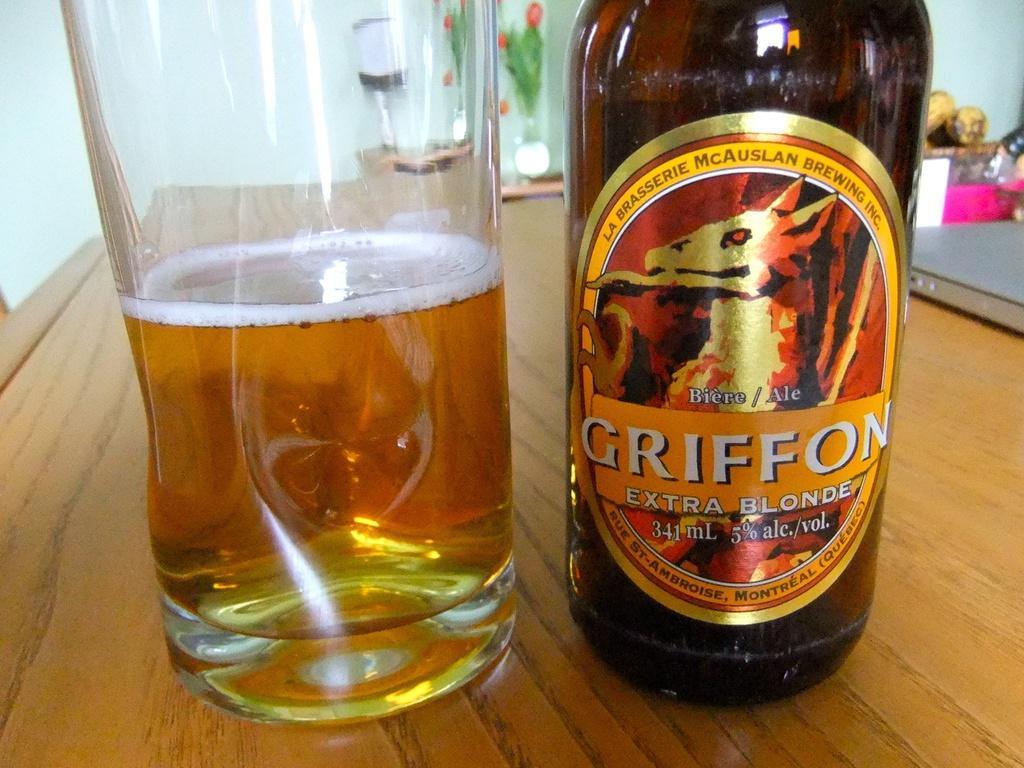In one or two sentences, can you explain what this image depicts? This image consists of a glass and a bottle. In which there is wine. At the bottom, there is a table. In the background, we can see a wall. In the middle, there is a flower vase. 